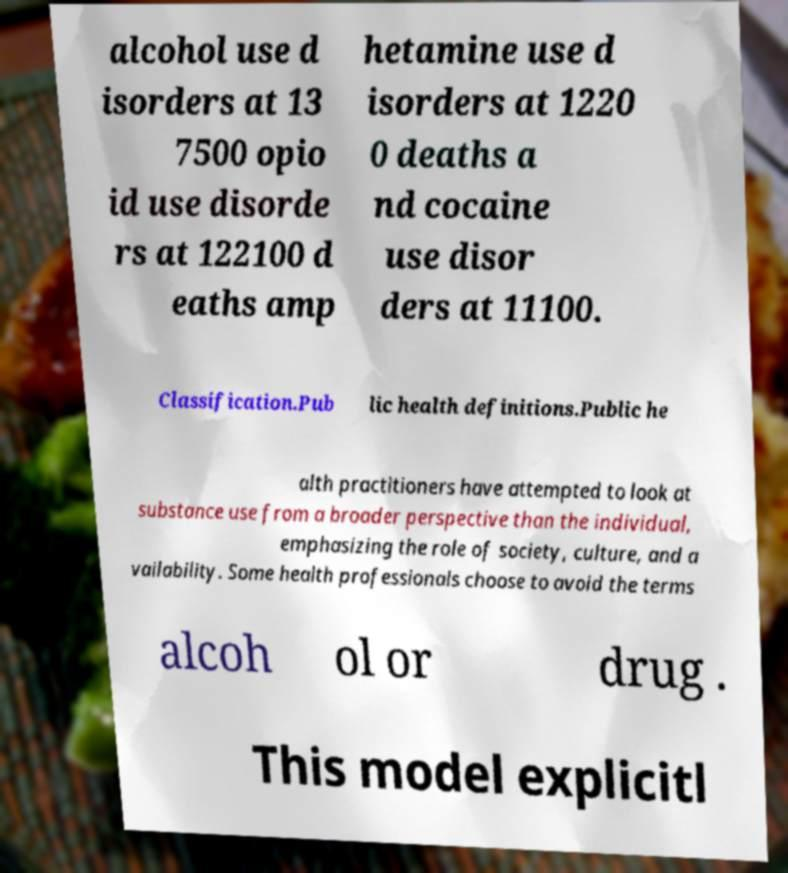For documentation purposes, I need the text within this image transcribed. Could you provide that? alcohol use d isorders at 13 7500 opio id use disorde rs at 122100 d eaths amp hetamine use d isorders at 1220 0 deaths a nd cocaine use disor ders at 11100. Classification.Pub lic health definitions.Public he alth practitioners have attempted to look at substance use from a broader perspective than the individual, emphasizing the role of society, culture, and a vailability. Some health professionals choose to avoid the terms alcoh ol or drug . This model explicitl 